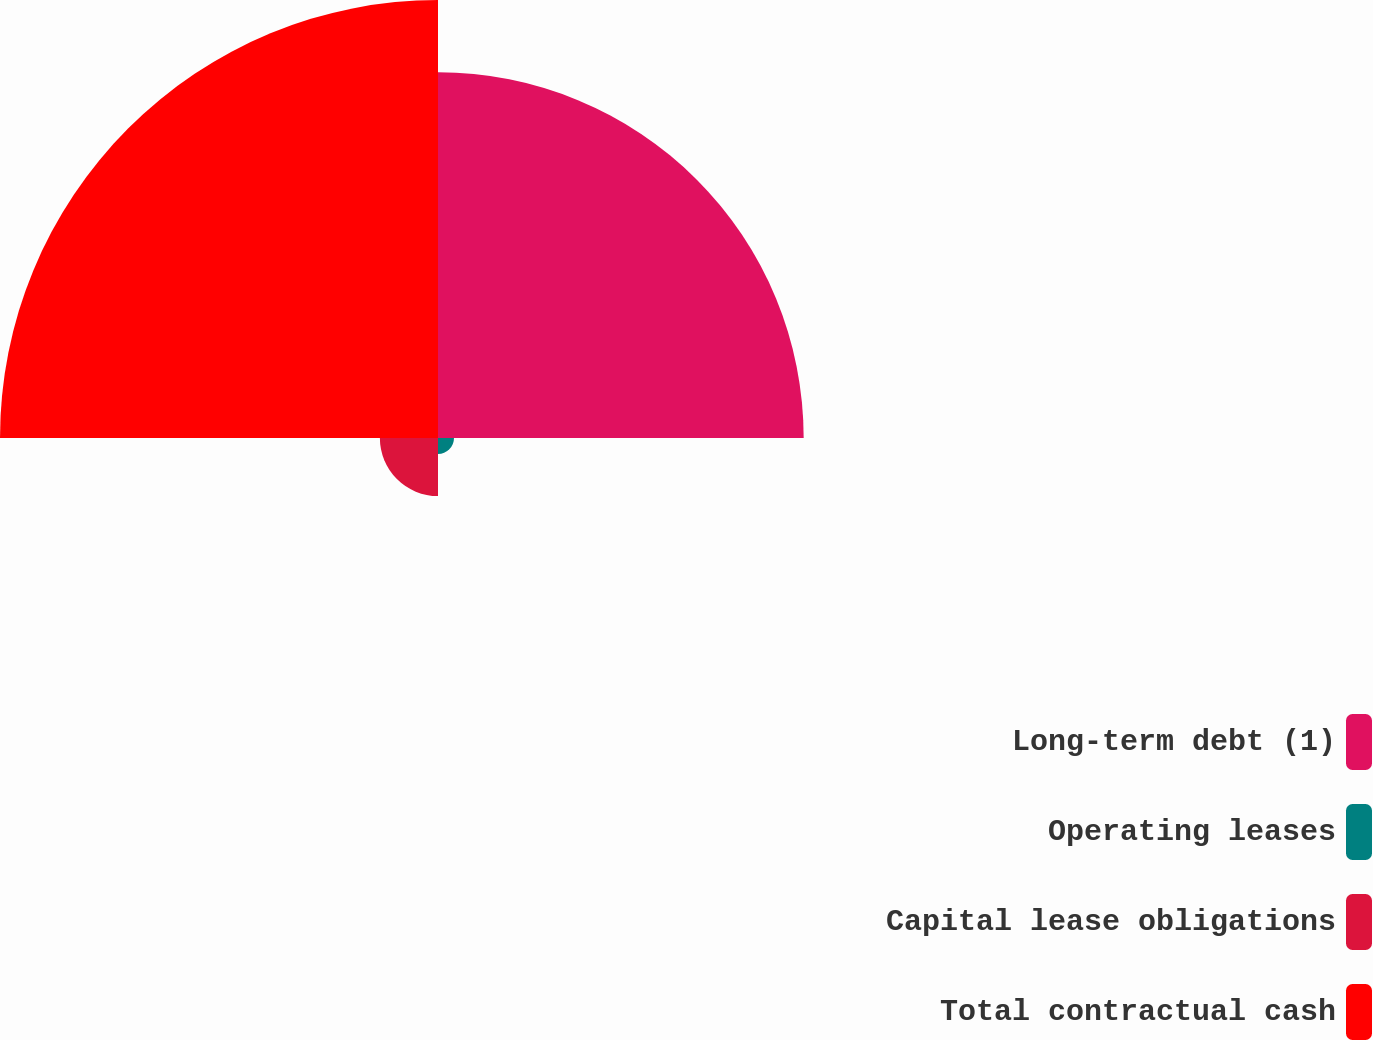<chart> <loc_0><loc_0><loc_500><loc_500><pie_chart><fcel>Long-term debt (1)<fcel>Operating leases<fcel>Capital lease obligations<fcel>Total contractual cash<nl><fcel>41.66%<fcel>1.82%<fcel>6.62%<fcel>49.9%<nl></chart> 